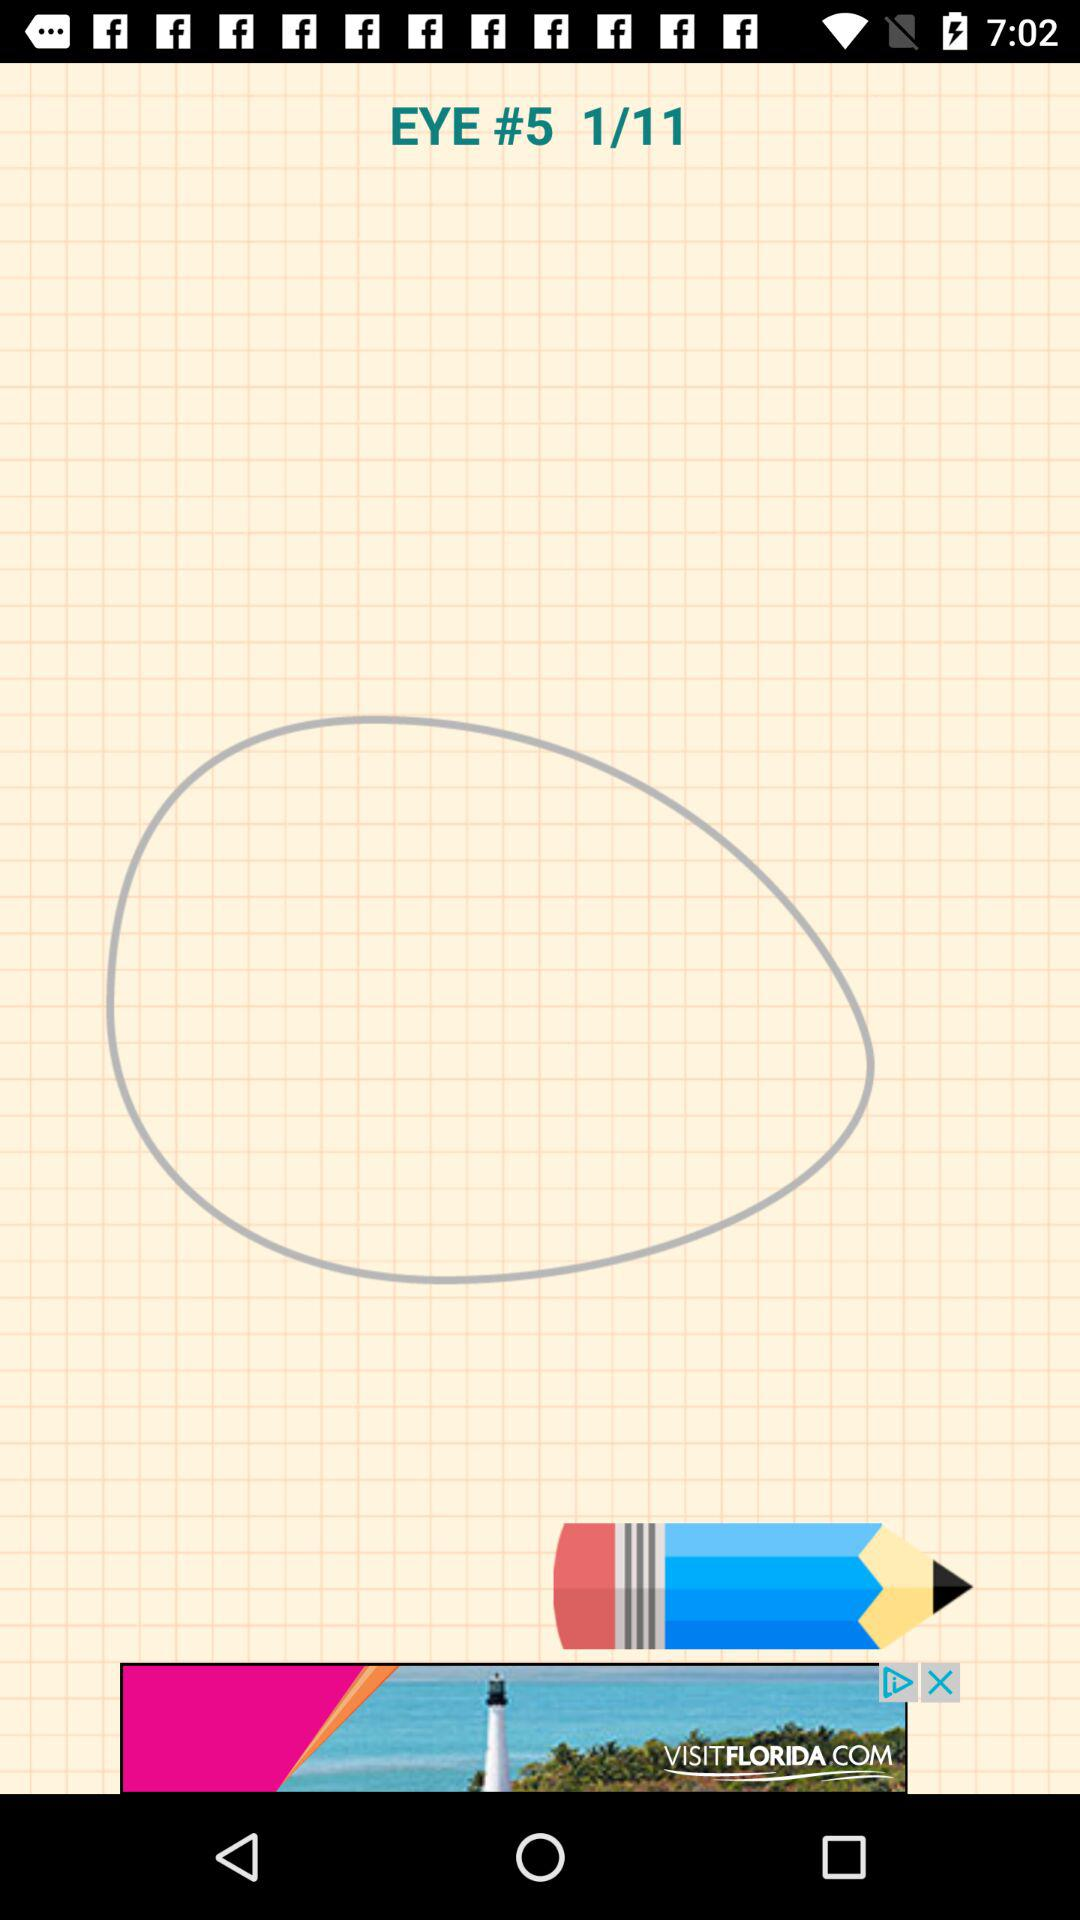On what page number are we right now? You are on page number 1. 